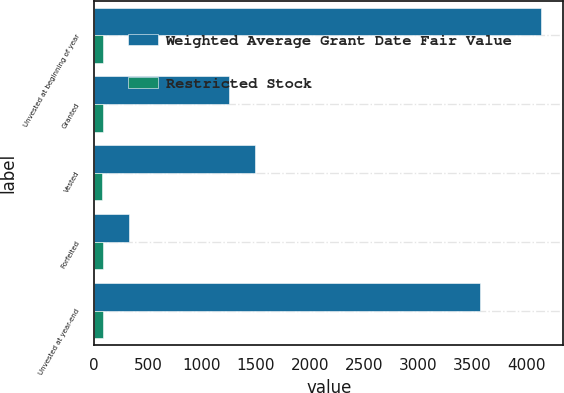<chart> <loc_0><loc_0><loc_500><loc_500><stacked_bar_chart><ecel><fcel>Unvested at beginning of year<fcel>Granted<fcel>Vested<fcel>Forfeited<fcel>Unvested at year-end<nl><fcel>Weighted Average Grant Date Fair Value<fcel>4138<fcel>1254<fcel>1495<fcel>326<fcel>3571<nl><fcel>Restricted Stock<fcel>80.8<fcel>82.37<fcel>71.3<fcel>83.86<fcel>85.04<nl></chart> 